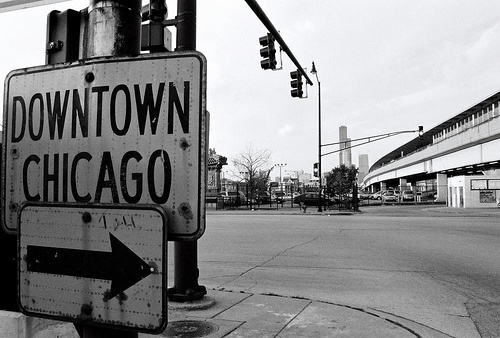Describe the objects in this image and their specific colors. I can see traffic light in lightgray, black, and gray tones, car in black, gray, and lightgray tones, car in lightgray, black, gray, and darkgray tones, traffic light in lightgray, black, gray, white, and darkgray tones, and car in lightgray, black, and gray tones in this image. 